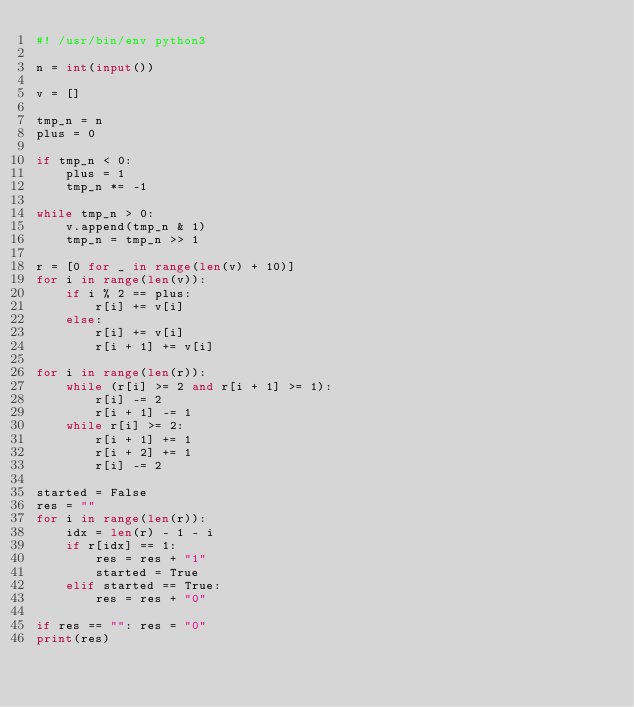Convert code to text. <code><loc_0><loc_0><loc_500><loc_500><_Python_>#! /usr/bin/env python3

n = int(input())

v = []

tmp_n = n
plus = 0

if tmp_n < 0:
    plus = 1
    tmp_n *= -1

while tmp_n > 0:
    v.append(tmp_n & 1)
    tmp_n = tmp_n >> 1

r = [0 for _ in range(len(v) + 10)]
for i in range(len(v)):
    if i % 2 == plus:
        r[i] += v[i]
    else:
        r[i] += v[i]
        r[i + 1] += v[i]

for i in range(len(r)):
    while (r[i] >= 2 and r[i + 1] >= 1):
        r[i] -= 2
        r[i + 1] -= 1
    while r[i] >= 2:
        r[i + 1] += 1
        r[i + 2] += 1
        r[i] -= 2

started = False
res = ""
for i in range(len(r)):
    idx = len(r) - 1 - i
    if r[idx] == 1:
        res = res + "1"
        started = True
    elif started == True:
        res = res + "0"

if res == "": res = "0"
print(res)
</code> 